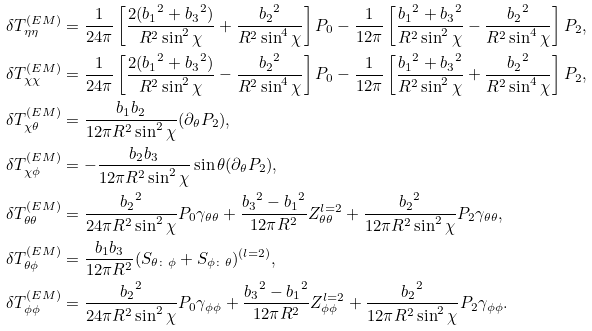<formula> <loc_0><loc_0><loc_500><loc_500>\delta T _ { \eta \eta } ^ { ( E M ) } & = \frac { 1 } { 2 4 \pi } \left [ \frac { 2 ( { b _ { 1 } } ^ { 2 } + { b _ { 3 } } ^ { 2 } ) } { R ^ { 2 } \sin ^ { 2 } \chi } + \frac { { b _ { 2 } } ^ { 2 } } { R ^ { 2 } \sin ^ { 4 } \chi } \right ] P _ { 0 } - \frac { 1 } { 1 2 \pi } \left [ \frac { { b _ { 1 } } ^ { 2 } + { b _ { 3 } } ^ { 2 } } { R ^ { 2 } \sin ^ { 2 } \chi } - \frac { { b _ { 2 } } ^ { 2 } } { R ^ { 2 } \sin ^ { 4 } \chi } \right ] P _ { 2 } , \\ \delta T _ { \chi \chi } ^ { ( E M ) } & = \frac { 1 } { 2 4 \pi } \left [ \frac { 2 ( { b _ { 1 } } ^ { 2 } + { b _ { 3 } } ^ { 2 } ) } { R ^ { 2 } \sin ^ { 2 } \chi } - \frac { { b _ { 2 } } ^ { 2 } } { R ^ { 2 } \sin ^ { 4 } \chi } \right ] P _ { 0 } - \frac { 1 } { 1 2 \pi } \left [ \frac { { b _ { 1 } } ^ { 2 } + { b _ { 3 } } ^ { 2 } } { R ^ { 2 } \sin ^ { 2 } \chi } + \frac { { b _ { 2 } } ^ { 2 } } { R ^ { 2 } \sin ^ { 4 } \chi } \right ] P _ { 2 } , \\ \delta T _ { \chi \theta } ^ { ( E M ) } & = \frac { { b _ { 1 } } { b _ { 2 } } } { 1 2 \pi R ^ { 2 } \sin ^ { 2 } \chi } ( \partial _ { \theta } P _ { 2 } ) , \\ \delta T _ { \chi \phi } ^ { ( E M ) } & = - \frac { { b _ { 2 } } { b _ { 3 } } } { 1 2 \pi R ^ { 2 } \sin ^ { 2 } \chi } \sin \theta ( \partial _ { \theta } P _ { 2 } ) , \\ \delta T _ { \theta \theta } ^ { ( E M ) } & = \frac { { b _ { 2 } } ^ { 2 } } { 2 4 \pi R ^ { 2 } \sin ^ { 2 } \chi } P _ { 0 } \gamma _ { \theta \theta } + \frac { { b _ { 3 } } ^ { 2 } - { b _ { 1 } } ^ { 2 } } { 1 2 \pi R ^ { 2 } } Z _ { \theta \theta } ^ { l = 2 } + \frac { { b _ { 2 } } ^ { 2 } } { 1 2 \pi R ^ { 2 } \sin ^ { 2 } \chi } P _ { 2 } \gamma _ { \theta \theta } , \\ \delta T _ { \theta \phi } ^ { ( E M ) } & = \frac { { b _ { 1 } } { b _ { 3 } } } { 1 2 \pi R ^ { 2 } } ( S _ { \theta \colon \phi } + S _ { \phi \colon \theta } ) ^ { ( l = 2 ) } , \\ \delta T _ { \phi \phi } ^ { ( E M ) } & = \frac { { b _ { 2 } } ^ { 2 } } { 2 4 \pi R ^ { 2 } \sin ^ { 2 } \chi } P _ { 0 } \gamma _ { \phi \phi } + \frac { { b _ { 3 } } ^ { 2 } - { b _ { 1 } } ^ { 2 } } { 1 2 \pi R ^ { 2 } } Z _ { \phi \phi } ^ { l = 2 } + \frac { { b _ { 2 } } ^ { 2 } } { 1 2 \pi R ^ { 2 } \sin ^ { 2 } \chi } P _ { 2 } \gamma _ { \phi \phi } .</formula> 